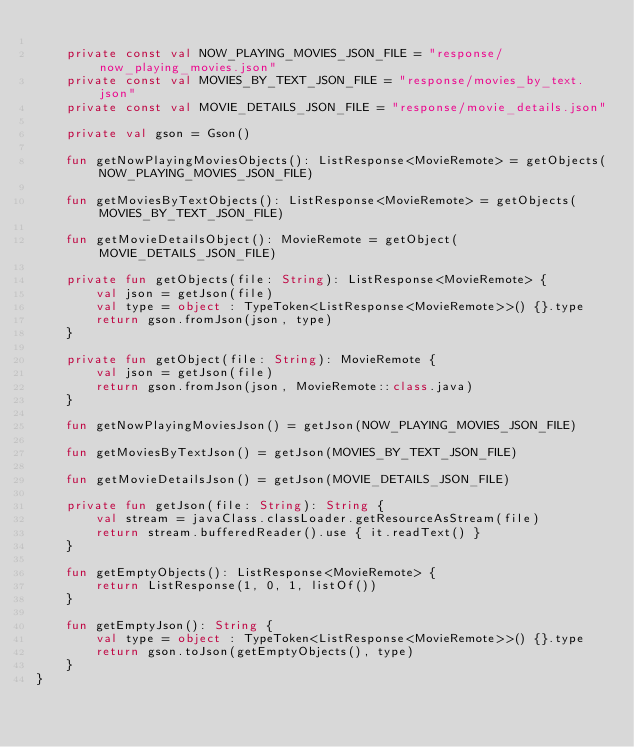Convert code to text. <code><loc_0><loc_0><loc_500><loc_500><_Kotlin_>
    private const val NOW_PLAYING_MOVIES_JSON_FILE = "response/now_playing_movies.json"
    private const val MOVIES_BY_TEXT_JSON_FILE = "response/movies_by_text.json"
    private const val MOVIE_DETAILS_JSON_FILE = "response/movie_details.json"

    private val gson = Gson()

    fun getNowPlayingMoviesObjects(): ListResponse<MovieRemote> = getObjects(NOW_PLAYING_MOVIES_JSON_FILE)

    fun getMoviesByTextObjects(): ListResponse<MovieRemote> = getObjects(MOVIES_BY_TEXT_JSON_FILE)

    fun getMovieDetailsObject(): MovieRemote = getObject(MOVIE_DETAILS_JSON_FILE)

    private fun getObjects(file: String): ListResponse<MovieRemote> {
        val json = getJson(file)
        val type = object : TypeToken<ListResponse<MovieRemote>>() {}.type
        return gson.fromJson(json, type)
    }

    private fun getObject(file: String): MovieRemote {
        val json = getJson(file)
        return gson.fromJson(json, MovieRemote::class.java)
    }

    fun getNowPlayingMoviesJson() = getJson(NOW_PLAYING_MOVIES_JSON_FILE)

    fun getMoviesByTextJson() = getJson(MOVIES_BY_TEXT_JSON_FILE)

    fun getMovieDetailsJson() = getJson(MOVIE_DETAILS_JSON_FILE)

    private fun getJson(file: String): String {
        val stream = javaClass.classLoader.getResourceAsStream(file)
        return stream.bufferedReader().use { it.readText() }
    }

    fun getEmptyObjects(): ListResponse<MovieRemote> {
        return ListResponse(1, 0, 1, listOf())
    }

    fun getEmptyJson(): String {
        val type = object : TypeToken<ListResponse<MovieRemote>>() {}.type
        return gson.toJson(getEmptyObjects(), type)
    }
}</code> 